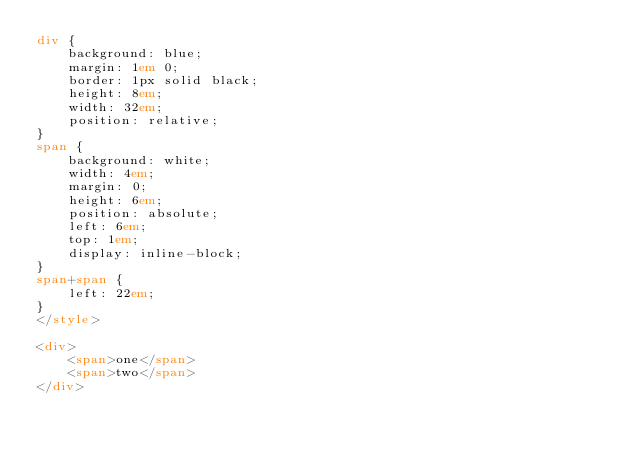Convert code to text. <code><loc_0><loc_0><loc_500><loc_500><_HTML_>div {
	background: blue;
	margin: 1em 0;
	border: 1px solid black;
	height: 8em;
	width: 32em;
	position: relative;
}
span {
	background: white;
	width: 4em;
	margin: 0;
	height: 6em;
	position: absolute;
	left: 6em;
	top: 1em;
	display: inline-block;
}
span+span {
	left: 22em;
}
</style>

<div>
	<span>one</span>
	<span>two</span>
</div>
</code> 